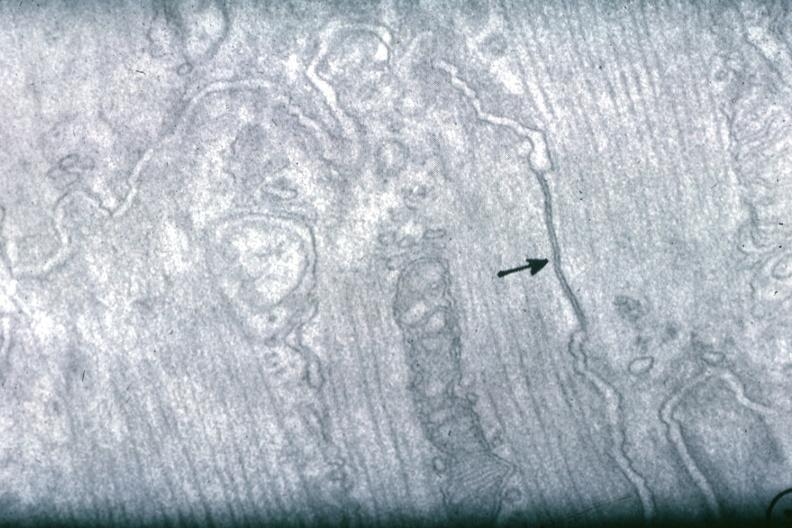how many cells does this image show junctional complex between?
Answer the question using a single word or phrase. Two 